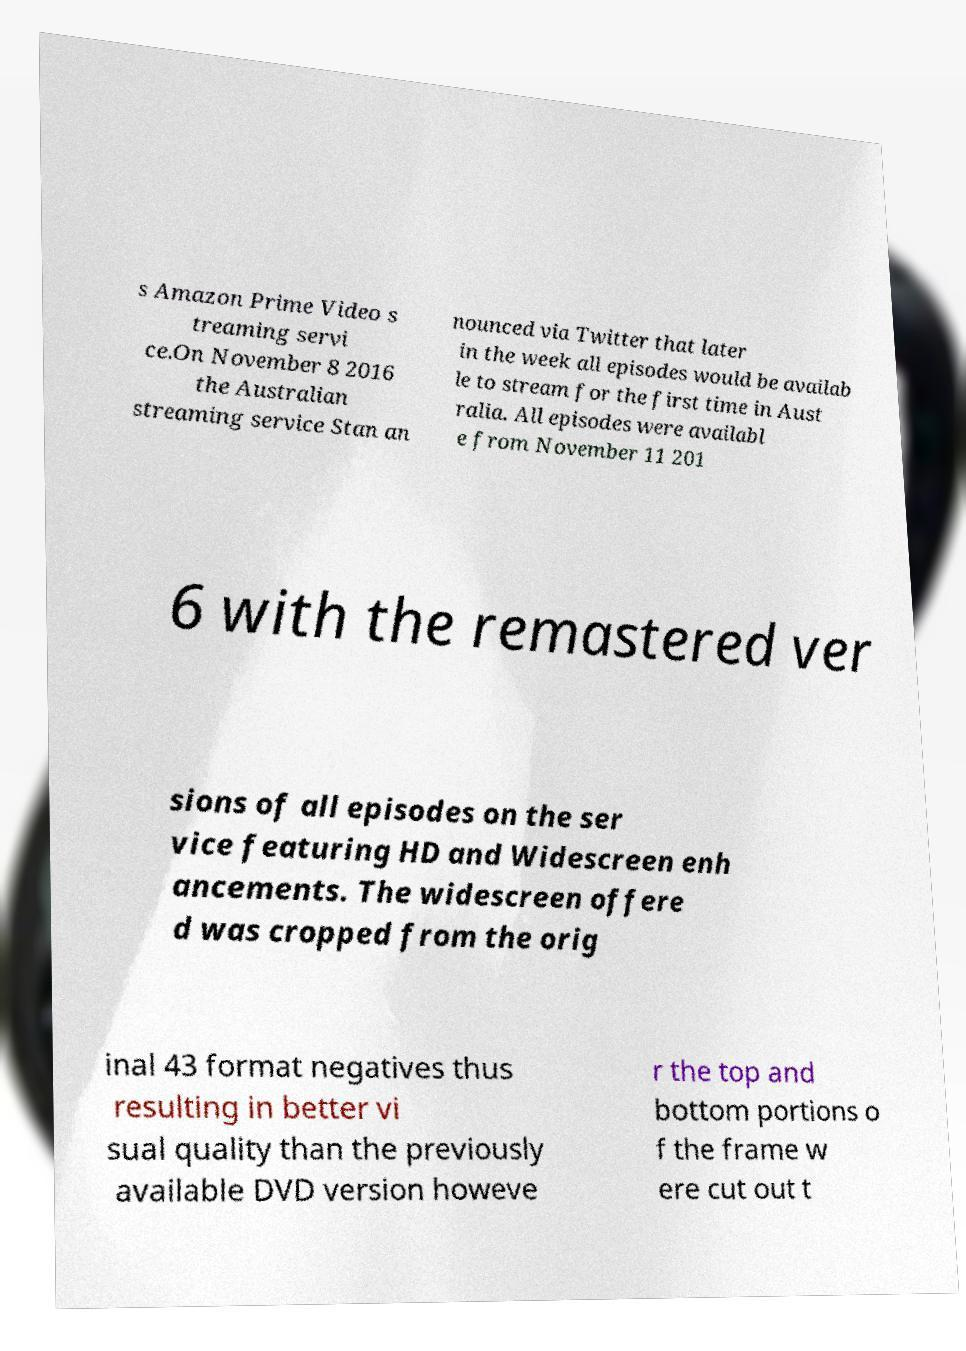Please identify and transcribe the text found in this image. s Amazon Prime Video s treaming servi ce.On November 8 2016 the Australian streaming service Stan an nounced via Twitter that later in the week all episodes would be availab le to stream for the first time in Aust ralia. All episodes were availabl e from November 11 201 6 with the remastered ver sions of all episodes on the ser vice featuring HD and Widescreen enh ancements. The widescreen offere d was cropped from the orig inal 43 format negatives thus resulting in better vi sual quality than the previously available DVD version howeve r the top and bottom portions o f the frame w ere cut out t 